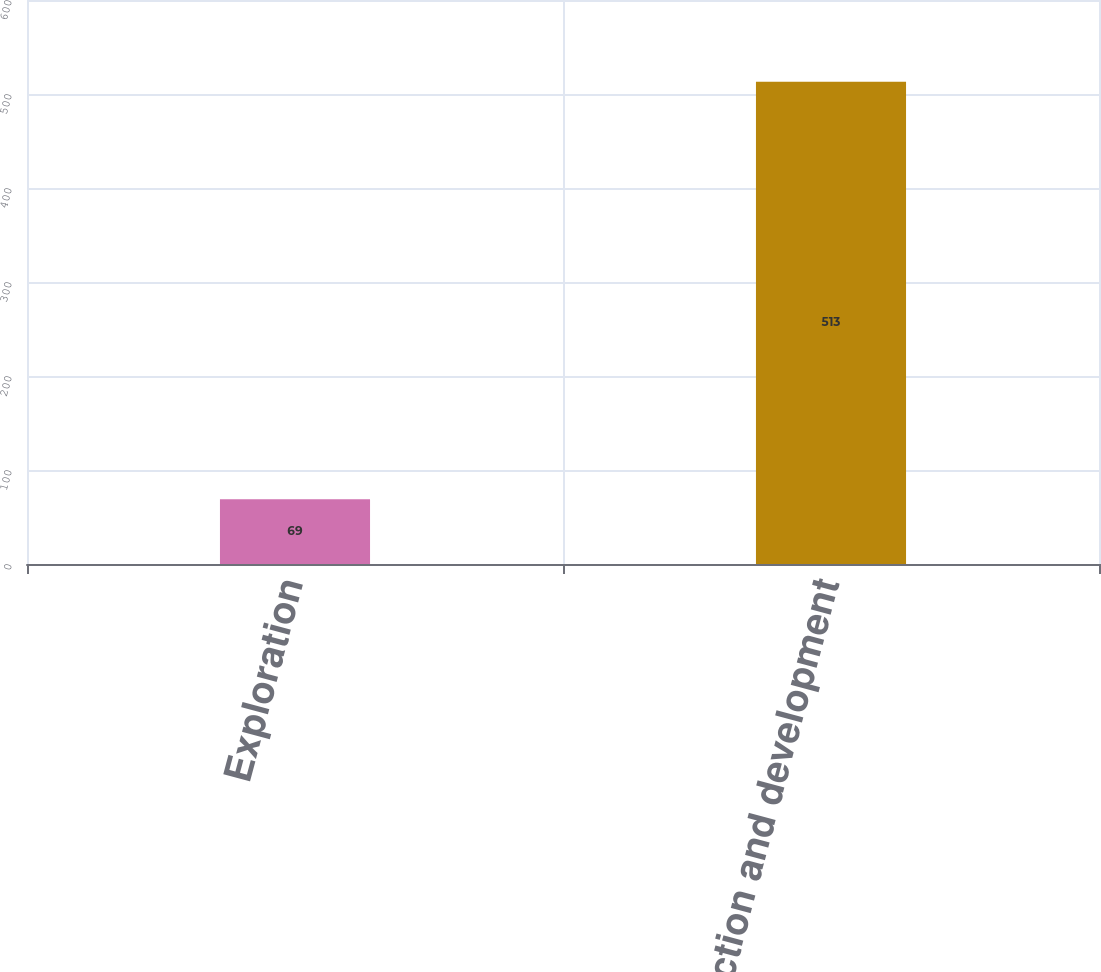Convert chart. <chart><loc_0><loc_0><loc_500><loc_500><bar_chart><fcel>Exploration<fcel>Production and development<nl><fcel>69<fcel>513<nl></chart> 